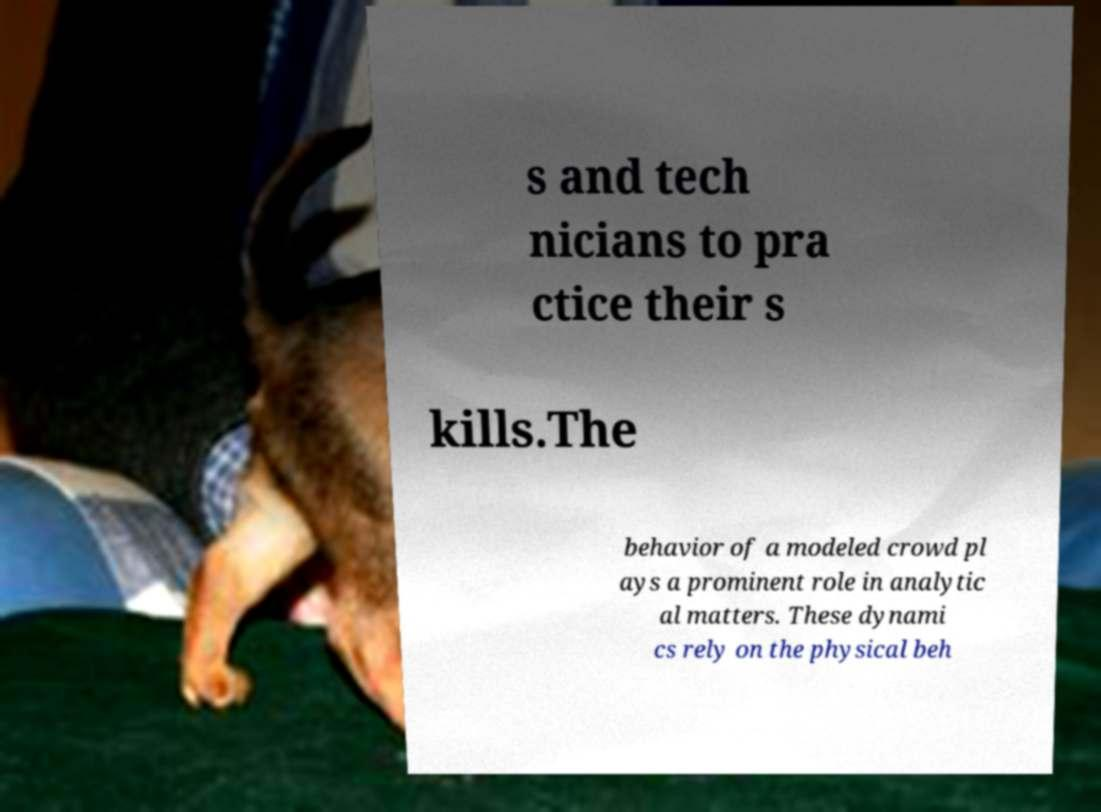There's text embedded in this image that I need extracted. Can you transcribe it verbatim? s and tech nicians to pra ctice their s kills.The behavior of a modeled crowd pl ays a prominent role in analytic al matters. These dynami cs rely on the physical beh 